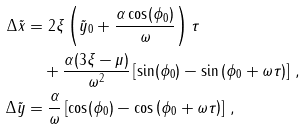Convert formula to latex. <formula><loc_0><loc_0><loc_500><loc_500>\Delta \tilde { x } & = 2 \xi \left ( \tilde { y } _ { 0 } + \frac { \alpha \cos ( \phi _ { 0 } ) } { \omega } \right ) \tau \\ & \quad + \frac { \alpha ( 3 \xi - \mu ) } { \omega ^ { 2 } } \left [ \sin ( \phi _ { 0 } ) - \sin \left ( \phi _ { 0 } + \omega \tau \right ) \right ] \, , \\ \Delta \tilde { y } & = \frac { \alpha } { \omega } \left [ \cos ( \phi _ { 0 } ) - \cos \left ( \phi _ { 0 } + \omega \tau \right ) \right ] \, ,</formula> 